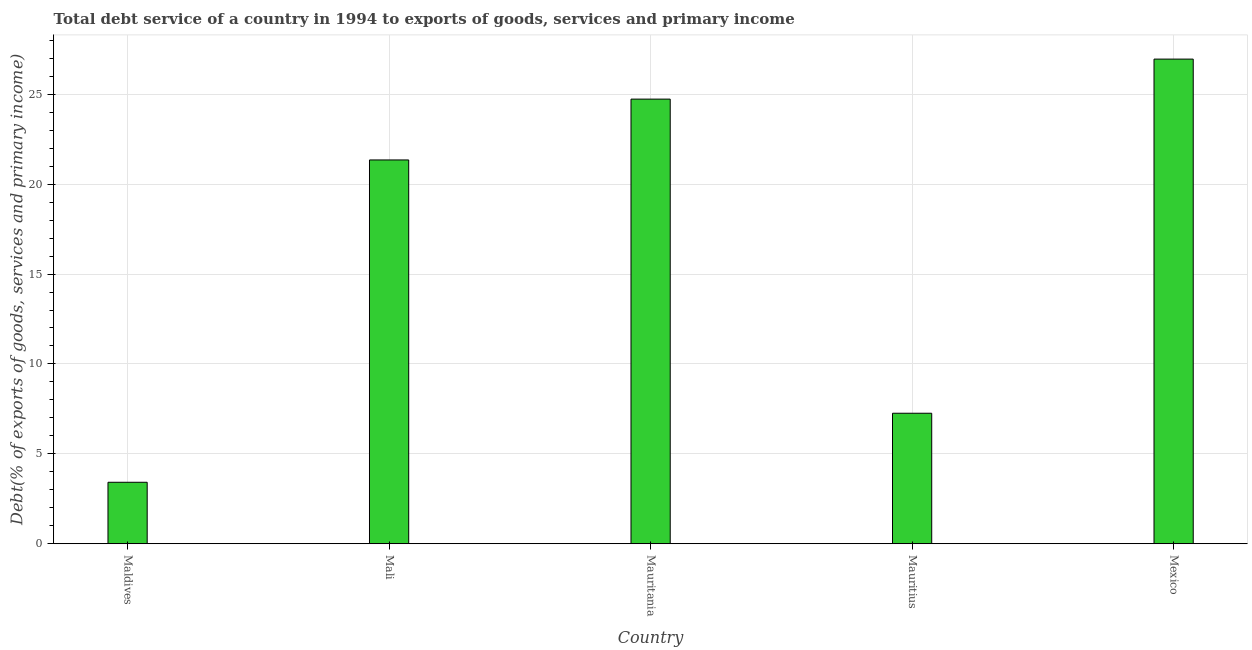Does the graph contain any zero values?
Your answer should be compact. No. Does the graph contain grids?
Keep it short and to the point. Yes. What is the title of the graph?
Provide a succinct answer. Total debt service of a country in 1994 to exports of goods, services and primary income. What is the label or title of the X-axis?
Your response must be concise. Country. What is the label or title of the Y-axis?
Give a very brief answer. Debt(% of exports of goods, services and primary income). What is the total debt service in Mexico?
Your response must be concise. 26.95. Across all countries, what is the maximum total debt service?
Ensure brevity in your answer.  26.95. Across all countries, what is the minimum total debt service?
Your response must be concise. 3.42. In which country was the total debt service maximum?
Offer a terse response. Mexico. In which country was the total debt service minimum?
Provide a succinct answer. Maldives. What is the sum of the total debt service?
Your response must be concise. 83.71. What is the difference between the total debt service in Maldives and Mauritania?
Your answer should be very brief. -21.31. What is the average total debt service per country?
Offer a very short reply. 16.74. What is the median total debt service?
Provide a short and direct response. 21.35. What is the ratio of the total debt service in Mauritania to that in Mauritius?
Give a very brief answer. 3.41. Is the total debt service in Maldives less than that in Mauritania?
Offer a terse response. Yes. Is the difference between the total debt service in Maldives and Mauritania greater than the difference between any two countries?
Your response must be concise. No. What is the difference between the highest and the second highest total debt service?
Your answer should be very brief. 2.23. What is the difference between the highest and the lowest total debt service?
Your answer should be compact. 23.54. How many bars are there?
Your answer should be very brief. 5. Are all the bars in the graph horizontal?
Provide a succinct answer. No. What is the difference between two consecutive major ticks on the Y-axis?
Offer a terse response. 5. Are the values on the major ticks of Y-axis written in scientific E-notation?
Your response must be concise. No. What is the Debt(% of exports of goods, services and primary income) of Maldives?
Provide a short and direct response. 3.42. What is the Debt(% of exports of goods, services and primary income) of Mali?
Provide a short and direct response. 21.35. What is the Debt(% of exports of goods, services and primary income) of Mauritania?
Give a very brief answer. 24.73. What is the Debt(% of exports of goods, services and primary income) of Mauritius?
Provide a short and direct response. 7.26. What is the Debt(% of exports of goods, services and primary income) in Mexico?
Ensure brevity in your answer.  26.95. What is the difference between the Debt(% of exports of goods, services and primary income) in Maldives and Mali?
Provide a short and direct response. -17.93. What is the difference between the Debt(% of exports of goods, services and primary income) in Maldives and Mauritania?
Provide a short and direct response. -21.31. What is the difference between the Debt(% of exports of goods, services and primary income) in Maldives and Mauritius?
Your answer should be compact. -3.84. What is the difference between the Debt(% of exports of goods, services and primary income) in Maldives and Mexico?
Your response must be concise. -23.54. What is the difference between the Debt(% of exports of goods, services and primary income) in Mali and Mauritania?
Your answer should be compact. -3.38. What is the difference between the Debt(% of exports of goods, services and primary income) in Mali and Mauritius?
Keep it short and to the point. 14.09. What is the difference between the Debt(% of exports of goods, services and primary income) in Mali and Mexico?
Your answer should be very brief. -5.61. What is the difference between the Debt(% of exports of goods, services and primary income) in Mauritania and Mauritius?
Offer a terse response. 17.47. What is the difference between the Debt(% of exports of goods, services and primary income) in Mauritania and Mexico?
Provide a short and direct response. -2.23. What is the difference between the Debt(% of exports of goods, services and primary income) in Mauritius and Mexico?
Keep it short and to the point. -19.7. What is the ratio of the Debt(% of exports of goods, services and primary income) in Maldives to that in Mali?
Offer a very short reply. 0.16. What is the ratio of the Debt(% of exports of goods, services and primary income) in Maldives to that in Mauritania?
Provide a short and direct response. 0.14. What is the ratio of the Debt(% of exports of goods, services and primary income) in Maldives to that in Mauritius?
Your answer should be compact. 0.47. What is the ratio of the Debt(% of exports of goods, services and primary income) in Maldives to that in Mexico?
Your answer should be compact. 0.13. What is the ratio of the Debt(% of exports of goods, services and primary income) in Mali to that in Mauritania?
Provide a short and direct response. 0.86. What is the ratio of the Debt(% of exports of goods, services and primary income) in Mali to that in Mauritius?
Give a very brief answer. 2.94. What is the ratio of the Debt(% of exports of goods, services and primary income) in Mali to that in Mexico?
Your response must be concise. 0.79. What is the ratio of the Debt(% of exports of goods, services and primary income) in Mauritania to that in Mauritius?
Your answer should be compact. 3.41. What is the ratio of the Debt(% of exports of goods, services and primary income) in Mauritania to that in Mexico?
Your response must be concise. 0.92. What is the ratio of the Debt(% of exports of goods, services and primary income) in Mauritius to that in Mexico?
Make the answer very short. 0.27. 